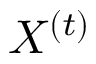<formula> <loc_0><loc_0><loc_500><loc_500>X ^ { ( t ) }</formula> 